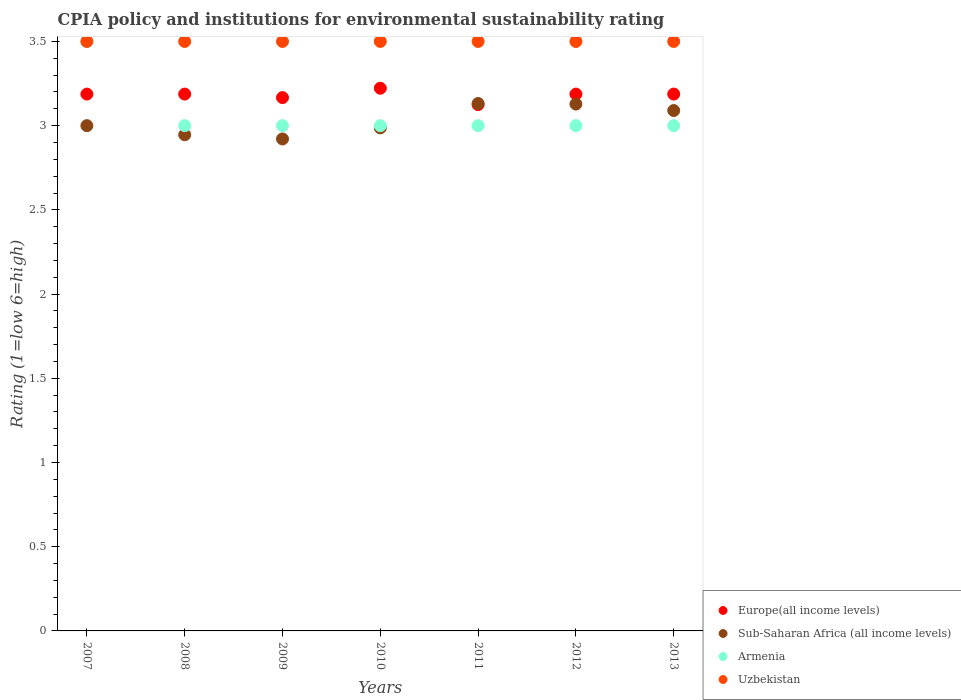How many different coloured dotlines are there?
Ensure brevity in your answer.  4. What is the CPIA rating in Sub-Saharan Africa (all income levels) in 2010?
Provide a short and direct response. 2.99. Across all years, what is the maximum CPIA rating in Uzbekistan?
Offer a very short reply. 3.5. Across all years, what is the minimum CPIA rating in Sub-Saharan Africa (all income levels)?
Offer a very short reply. 2.92. What is the total CPIA rating in Uzbekistan in the graph?
Ensure brevity in your answer.  24.5. What is the difference between the CPIA rating in Sub-Saharan Africa (all income levels) in 2009 and the CPIA rating in Uzbekistan in 2007?
Your response must be concise. -0.58. What is the average CPIA rating in Armenia per year?
Ensure brevity in your answer.  3.07. In the year 2007, what is the difference between the CPIA rating in Uzbekistan and CPIA rating in Sub-Saharan Africa (all income levels)?
Keep it short and to the point. 0.5. What is the ratio of the CPIA rating in Uzbekistan in 2008 to that in 2009?
Give a very brief answer. 1. Is the difference between the CPIA rating in Uzbekistan in 2008 and 2009 greater than the difference between the CPIA rating in Sub-Saharan Africa (all income levels) in 2008 and 2009?
Provide a succinct answer. No. What is the difference between the highest and the second highest CPIA rating in Sub-Saharan Africa (all income levels)?
Offer a terse response. 0. What is the difference between the highest and the lowest CPIA rating in Uzbekistan?
Ensure brevity in your answer.  0. In how many years, is the CPIA rating in Uzbekistan greater than the average CPIA rating in Uzbekistan taken over all years?
Keep it short and to the point. 0. Is the sum of the CPIA rating in Europe(all income levels) in 2010 and 2011 greater than the maximum CPIA rating in Armenia across all years?
Give a very brief answer. Yes. Is it the case that in every year, the sum of the CPIA rating in Armenia and CPIA rating in Europe(all income levels)  is greater than the CPIA rating in Uzbekistan?
Keep it short and to the point. Yes. Is the CPIA rating in Armenia strictly greater than the CPIA rating in Sub-Saharan Africa (all income levels) over the years?
Provide a succinct answer. No. Is the CPIA rating in Armenia strictly less than the CPIA rating in Sub-Saharan Africa (all income levels) over the years?
Your answer should be very brief. No. What is the difference between two consecutive major ticks on the Y-axis?
Your answer should be very brief. 0.5. Are the values on the major ticks of Y-axis written in scientific E-notation?
Provide a succinct answer. No. Does the graph contain any zero values?
Your answer should be very brief. No. Does the graph contain grids?
Your response must be concise. No. How are the legend labels stacked?
Give a very brief answer. Vertical. What is the title of the graph?
Ensure brevity in your answer.  CPIA policy and institutions for environmental sustainability rating. Does "French Polynesia" appear as one of the legend labels in the graph?
Your answer should be compact. No. What is the label or title of the X-axis?
Make the answer very short. Years. What is the label or title of the Y-axis?
Ensure brevity in your answer.  Rating (1=low 6=high). What is the Rating (1=low 6=high) in Europe(all income levels) in 2007?
Offer a very short reply. 3.19. What is the Rating (1=low 6=high) in Sub-Saharan Africa (all income levels) in 2007?
Give a very brief answer. 3. What is the Rating (1=low 6=high) of Armenia in 2007?
Your answer should be compact. 3.5. What is the Rating (1=low 6=high) of Uzbekistan in 2007?
Your answer should be compact. 3.5. What is the Rating (1=low 6=high) of Europe(all income levels) in 2008?
Give a very brief answer. 3.19. What is the Rating (1=low 6=high) of Sub-Saharan Africa (all income levels) in 2008?
Offer a terse response. 2.95. What is the Rating (1=low 6=high) of Uzbekistan in 2008?
Give a very brief answer. 3.5. What is the Rating (1=low 6=high) of Europe(all income levels) in 2009?
Your response must be concise. 3.17. What is the Rating (1=low 6=high) in Sub-Saharan Africa (all income levels) in 2009?
Offer a terse response. 2.92. What is the Rating (1=low 6=high) in Armenia in 2009?
Your answer should be very brief. 3. What is the Rating (1=low 6=high) of Uzbekistan in 2009?
Your answer should be very brief. 3.5. What is the Rating (1=low 6=high) in Europe(all income levels) in 2010?
Make the answer very short. 3.22. What is the Rating (1=low 6=high) in Sub-Saharan Africa (all income levels) in 2010?
Keep it short and to the point. 2.99. What is the Rating (1=low 6=high) of Armenia in 2010?
Provide a short and direct response. 3. What is the Rating (1=low 6=high) of Uzbekistan in 2010?
Ensure brevity in your answer.  3.5. What is the Rating (1=low 6=high) of Europe(all income levels) in 2011?
Your response must be concise. 3.12. What is the Rating (1=low 6=high) of Sub-Saharan Africa (all income levels) in 2011?
Your answer should be compact. 3.13. What is the Rating (1=low 6=high) in Uzbekistan in 2011?
Ensure brevity in your answer.  3.5. What is the Rating (1=low 6=high) of Europe(all income levels) in 2012?
Give a very brief answer. 3.19. What is the Rating (1=low 6=high) of Sub-Saharan Africa (all income levels) in 2012?
Your answer should be compact. 3.13. What is the Rating (1=low 6=high) in Uzbekistan in 2012?
Your answer should be compact. 3.5. What is the Rating (1=low 6=high) in Europe(all income levels) in 2013?
Give a very brief answer. 3.19. What is the Rating (1=low 6=high) of Sub-Saharan Africa (all income levels) in 2013?
Provide a short and direct response. 3.09. Across all years, what is the maximum Rating (1=low 6=high) in Europe(all income levels)?
Provide a short and direct response. 3.22. Across all years, what is the maximum Rating (1=low 6=high) of Sub-Saharan Africa (all income levels)?
Make the answer very short. 3.13. Across all years, what is the maximum Rating (1=low 6=high) of Armenia?
Offer a terse response. 3.5. Across all years, what is the minimum Rating (1=low 6=high) of Europe(all income levels)?
Provide a short and direct response. 3.12. Across all years, what is the minimum Rating (1=low 6=high) in Sub-Saharan Africa (all income levels)?
Your answer should be compact. 2.92. What is the total Rating (1=low 6=high) of Europe(all income levels) in the graph?
Offer a very short reply. 22.26. What is the total Rating (1=low 6=high) of Sub-Saharan Africa (all income levels) in the graph?
Your answer should be compact. 21.2. What is the total Rating (1=low 6=high) of Uzbekistan in the graph?
Ensure brevity in your answer.  24.5. What is the difference between the Rating (1=low 6=high) in Sub-Saharan Africa (all income levels) in 2007 and that in 2008?
Your answer should be compact. 0.05. What is the difference between the Rating (1=low 6=high) in Europe(all income levels) in 2007 and that in 2009?
Your response must be concise. 0.02. What is the difference between the Rating (1=low 6=high) of Sub-Saharan Africa (all income levels) in 2007 and that in 2009?
Your answer should be very brief. 0.08. What is the difference between the Rating (1=low 6=high) in Uzbekistan in 2007 and that in 2009?
Your response must be concise. 0. What is the difference between the Rating (1=low 6=high) of Europe(all income levels) in 2007 and that in 2010?
Provide a short and direct response. -0.03. What is the difference between the Rating (1=low 6=high) of Sub-Saharan Africa (all income levels) in 2007 and that in 2010?
Offer a terse response. 0.01. What is the difference between the Rating (1=low 6=high) in Armenia in 2007 and that in 2010?
Your answer should be very brief. 0.5. What is the difference between the Rating (1=low 6=high) in Uzbekistan in 2007 and that in 2010?
Offer a very short reply. 0. What is the difference between the Rating (1=low 6=high) in Europe(all income levels) in 2007 and that in 2011?
Your response must be concise. 0.06. What is the difference between the Rating (1=low 6=high) in Sub-Saharan Africa (all income levels) in 2007 and that in 2011?
Make the answer very short. -0.13. What is the difference between the Rating (1=low 6=high) of Armenia in 2007 and that in 2011?
Provide a succinct answer. 0.5. What is the difference between the Rating (1=low 6=high) in Europe(all income levels) in 2007 and that in 2012?
Offer a terse response. 0. What is the difference between the Rating (1=low 6=high) in Sub-Saharan Africa (all income levels) in 2007 and that in 2012?
Give a very brief answer. -0.13. What is the difference between the Rating (1=low 6=high) in Sub-Saharan Africa (all income levels) in 2007 and that in 2013?
Make the answer very short. -0.09. What is the difference between the Rating (1=low 6=high) of Armenia in 2007 and that in 2013?
Offer a very short reply. 0.5. What is the difference between the Rating (1=low 6=high) in Europe(all income levels) in 2008 and that in 2009?
Make the answer very short. 0.02. What is the difference between the Rating (1=low 6=high) in Sub-Saharan Africa (all income levels) in 2008 and that in 2009?
Provide a succinct answer. 0.02. What is the difference between the Rating (1=low 6=high) in Uzbekistan in 2008 and that in 2009?
Make the answer very short. 0. What is the difference between the Rating (1=low 6=high) in Europe(all income levels) in 2008 and that in 2010?
Give a very brief answer. -0.03. What is the difference between the Rating (1=low 6=high) of Sub-Saharan Africa (all income levels) in 2008 and that in 2010?
Make the answer very short. -0.04. What is the difference between the Rating (1=low 6=high) in Armenia in 2008 and that in 2010?
Make the answer very short. 0. What is the difference between the Rating (1=low 6=high) of Europe(all income levels) in 2008 and that in 2011?
Offer a terse response. 0.06. What is the difference between the Rating (1=low 6=high) in Sub-Saharan Africa (all income levels) in 2008 and that in 2011?
Your answer should be very brief. -0.19. What is the difference between the Rating (1=low 6=high) in Armenia in 2008 and that in 2011?
Offer a very short reply. 0. What is the difference between the Rating (1=low 6=high) of Europe(all income levels) in 2008 and that in 2012?
Give a very brief answer. 0. What is the difference between the Rating (1=low 6=high) of Sub-Saharan Africa (all income levels) in 2008 and that in 2012?
Your answer should be very brief. -0.18. What is the difference between the Rating (1=low 6=high) in Armenia in 2008 and that in 2012?
Your answer should be very brief. 0. What is the difference between the Rating (1=low 6=high) of Sub-Saharan Africa (all income levels) in 2008 and that in 2013?
Your response must be concise. -0.14. What is the difference between the Rating (1=low 6=high) in Uzbekistan in 2008 and that in 2013?
Your response must be concise. 0. What is the difference between the Rating (1=low 6=high) of Europe(all income levels) in 2009 and that in 2010?
Ensure brevity in your answer.  -0.06. What is the difference between the Rating (1=low 6=high) of Sub-Saharan Africa (all income levels) in 2009 and that in 2010?
Make the answer very short. -0.07. What is the difference between the Rating (1=low 6=high) in Armenia in 2009 and that in 2010?
Ensure brevity in your answer.  0. What is the difference between the Rating (1=low 6=high) in Europe(all income levels) in 2009 and that in 2011?
Keep it short and to the point. 0.04. What is the difference between the Rating (1=low 6=high) of Sub-Saharan Africa (all income levels) in 2009 and that in 2011?
Keep it short and to the point. -0.21. What is the difference between the Rating (1=low 6=high) in Uzbekistan in 2009 and that in 2011?
Your response must be concise. 0. What is the difference between the Rating (1=low 6=high) in Europe(all income levels) in 2009 and that in 2012?
Provide a succinct answer. -0.02. What is the difference between the Rating (1=low 6=high) of Sub-Saharan Africa (all income levels) in 2009 and that in 2012?
Offer a terse response. -0.21. What is the difference between the Rating (1=low 6=high) of Uzbekistan in 2009 and that in 2012?
Make the answer very short. 0. What is the difference between the Rating (1=low 6=high) in Europe(all income levels) in 2009 and that in 2013?
Keep it short and to the point. -0.02. What is the difference between the Rating (1=low 6=high) in Sub-Saharan Africa (all income levels) in 2009 and that in 2013?
Provide a succinct answer. -0.17. What is the difference between the Rating (1=low 6=high) of Europe(all income levels) in 2010 and that in 2011?
Your answer should be compact. 0.1. What is the difference between the Rating (1=low 6=high) in Sub-Saharan Africa (all income levels) in 2010 and that in 2011?
Provide a succinct answer. -0.14. What is the difference between the Rating (1=low 6=high) in Armenia in 2010 and that in 2011?
Your answer should be compact. 0. What is the difference between the Rating (1=low 6=high) in Europe(all income levels) in 2010 and that in 2012?
Make the answer very short. 0.03. What is the difference between the Rating (1=low 6=high) in Sub-Saharan Africa (all income levels) in 2010 and that in 2012?
Make the answer very short. -0.14. What is the difference between the Rating (1=low 6=high) of Armenia in 2010 and that in 2012?
Give a very brief answer. 0. What is the difference between the Rating (1=low 6=high) of Europe(all income levels) in 2010 and that in 2013?
Make the answer very short. 0.03. What is the difference between the Rating (1=low 6=high) in Sub-Saharan Africa (all income levels) in 2010 and that in 2013?
Provide a succinct answer. -0.1. What is the difference between the Rating (1=low 6=high) of Armenia in 2010 and that in 2013?
Offer a very short reply. 0. What is the difference between the Rating (1=low 6=high) of Uzbekistan in 2010 and that in 2013?
Keep it short and to the point. 0. What is the difference between the Rating (1=low 6=high) in Europe(all income levels) in 2011 and that in 2012?
Your answer should be very brief. -0.06. What is the difference between the Rating (1=low 6=high) in Sub-Saharan Africa (all income levels) in 2011 and that in 2012?
Give a very brief answer. 0. What is the difference between the Rating (1=low 6=high) in Armenia in 2011 and that in 2012?
Ensure brevity in your answer.  0. What is the difference between the Rating (1=low 6=high) in Uzbekistan in 2011 and that in 2012?
Provide a succinct answer. 0. What is the difference between the Rating (1=low 6=high) of Europe(all income levels) in 2011 and that in 2013?
Offer a very short reply. -0.06. What is the difference between the Rating (1=low 6=high) in Sub-Saharan Africa (all income levels) in 2011 and that in 2013?
Your response must be concise. 0.04. What is the difference between the Rating (1=low 6=high) in Armenia in 2011 and that in 2013?
Give a very brief answer. 0. What is the difference between the Rating (1=low 6=high) in Europe(all income levels) in 2012 and that in 2013?
Ensure brevity in your answer.  0. What is the difference between the Rating (1=low 6=high) in Sub-Saharan Africa (all income levels) in 2012 and that in 2013?
Make the answer very short. 0.04. What is the difference between the Rating (1=low 6=high) in Armenia in 2012 and that in 2013?
Your answer should be very brief. 0. What is the difference between the Rating (1=low 6=high) in Europe(all income levels) in 2007 and the Rating (1=low 6=high) in Sub-Saharan Africa (all income levels) in 2008?
Keep it short and to the point. 0.24. What is the difference between the Rating (1=low 6=high) in Europe(all income levels) in 2007 and the Rating (1=low 6=high) in Armenia in 2008?
Offer a very short reply. 0.19. What is the difference between the Rating (1=low 6=high) in Europe(all income levels) in 2007 and the Rating (1=low 6=high) in Uzbekistan in 2008?
Provide a short and direct response. -0.31. What is the difference between the Rating (1=low 6=high) in Sub-Saharan Africa (all income levels) in 2007 and the Rating (1=low 6=high) in Armenia in 2008?
Give a very brief answer. 0. What is the difference between the Rating (1=low 6=high) of Armenia in 2007 and the Rating (1=low 6=high) of Uzbekistan in 2008?
Ensure brevity in your answer.  0. What is the difference between the Rating (1=low 6=high) of Europe(all income levels) in 2007 and the Rating (1=low 6=high) of Sub-Saharan Africa (all income levels) in 2009?
Your answer should be compact. 0.27. What is the difference between the Rating (1=low 6=high) in Europe(all income levels) in 2007 and the Rating (1=low 6=high) in Armenia in 2009?
Ensure brevity in your answer.  0.19. What is the difference between the Rating (1=low 6=high) in Europe(all income levels) in 2007 and the Rating (1=low 6=high) in Uzbekistan in 2009?
Provide a succinct answer. -0.31. What is the difference between the Rating (1=low 6=high) in Armenia in 2007 and the Rating (1=low 6=high) in Uzbekistan in 2009?
Your answer should be very brief. 0. What is the difference between the Rating (1=low 6=high) in Europe(all income levels) in 2007 and the Rating (1=low 6=high) in Sub-Saharan Africa (all income levels) in 2010?
Make the answer very short. 0.2. What is the difference between the Rating (1=low 6=high) of Europe(all income levels) in 2007 and the Rating (1=low 6=high) of Armenia in 2010?
Offer a very short reply. 0.19. What is the difference between the Rating (1=low 6=high) in Europe(all income levels) in 2007 and the Rating (1=low 6=high) in Uzbekistan in 2010?
Offer a very short reply. -0.31. What is the difference between the Rating (1=low 6=high) in Sub-Saharan Africa (all income levels) in 2007 and the Rating (1=low 6=high) in Uzbekistan in 2010?
Offer a terse response. -0.5. What is the difference between the Rating (1=low 6=high) of Armenia in 2007 and the Rating (1=low 6=high) of Uzbekistan in 2010?
Offer a terse response. 0. What is the difference between the Rating (1=low 6=high) in Europe(all income levels) in 2007 and the Rating (1=low 6=high) in Sub-Saharan Africa (all income levels) in 2011?
Offer a terse response. 0.06. What is the difference between the Rating (1=low 6=high) of Europe(all income levels) in 2007 and the Rating (1=low 6=high) of Armenia in 2011?
Your answer should be very brief. 0.19. What is the difference between the Rating (1=low 6=high) in Europe(all income levels) in 2007 and the Rating (1=low 6=high) in Uzbekistan in 2011?
Your answer should be compact. -0.31. What is the difference between the Rating (1=low 6=high) in Sub-Saharan Africa (all income levels) in 2007 and the Rating (1=low 6=high) in Uzbekistan in 2011?
Your answer should be very brief. -0.5. What is the difference between the Rating (1=low 6=high) in Armenia in 2007 and the Rating (1=low 6=high) in Uzbekistan in 2011?
Ensure brevity in your answer.  0. What is the difference between the Rating (1=low 6=high) in Europe(all income levels) in 2007 and the Rating (1=low 6=high) in Sub-Saharan Africa (all income levels) in 2012?
Make the answer very short. 0.06. What is the difference between the Rating (1=low 6=high) in Europe(all income levels) in 2007 and the Rating (1=low 6=high) in Armenia in 2012?
Provide a succinct answer. 0.19. What is the difference between the Rating (1=low 6=high) in Europe(all income levels) in 2007 and the Rating (1=low 6=high) in Uzbekistan in 2012?
Your response must be concise. -0.31. What is the difference between the Rating (1=low 6=high) in Sub-Saharan Africa (all income levels) in 2007 and the Rating (1=low 6=high) in Armenia in 2012?
Ensure brevity in your answer.  0. What is the difference between the Rating (1=low 6=high) of Europe(all income levels) in 2007 and the Rating (1=low 6=high) of Sub-Saharan Africa (all income levels) in 2013?
Your answer should be very brief. 0.1. What is the difference between the Rating (1=low 6=high) in Europe(all income levels) in 2007 and the Rating (1=low 6=high) in Armenia in 2013?
Provide a short and direct response. 0.19. What is the difference between the Rating (1=low 6=high) in Europe(all income levels) in 2007 and the Rating (1=low 6=high) in Uzbekistan in 2013?
Ensure brevity in your answer.  -0.31. What is the difference between the Rating (1=low 6=high) in Sub-Saharan Africa (all income levels) in 2007 and the Rating (1=low 6=high) in Uzbekistan in 2013?
Your answer should be very brief. -0.5. What is the difference between the Rating (1=low 6=high) of Armenia in 2007 and the Rating (1=low 6=high) of Uzbekistan in 2013?
Your response must be concise. 0. What is the difference between the Rating (1=low 6=high) of Europe(all income levels) in 2008 and the Rating (1=low 6=high) of Sub-Saharan Africa (all income levels) in 2009?
Offer a very short reply. 0.27. What is the difference between the Rating (1=low 6=high) in Europe(all income levels) in 2008 and the Rating (1=low 6=high) in Armenia in 2009?
Keep it short and to the point. 0.19. What is the difference between the Rating (1=low 6=high) in Europe(all income levels) in 2008 and the Rating (1=low 6=high) in Uzbekistan in 2009?
Keep it short and to the point. -0.31. What is the difference between the Rating (1=low 6=high) in Sub-Saharan Africa (all income levels) in 2008 and the Rating (1=low 6=high) in Armenia in 2009?
Your answer should be compact. -0.05. What is the difference between the Rating (1=low 6=high) in Sub-Saharan Africa (all income levels) in 2008 and the Rating (1=low 6=high) in Uzbekistan in 2009?
Your answer should be compact. -0.55. What is the difference between the Rating (1=low 6=high) in Armenia in 2008 and the Rating (1=low 6=high) in Uzbekistan in 2009?
Provide a succinct answer. -0.5. What is the difference between the Rating (1=low 6=high) of Europe(all income levels) in 2008 and the Rating (1=low 6=high) of Sub-Saharan Africa (all income levels) in 2010?
Provide a short and direct response. 0.2. What is the difference between the Rating (1=low 6=high) of Europe(all income levels) in 2008 and the Rating (1=low 6=high) of Armenia in 2010?
Keep it short and to the point. 0.19. What is the difference between the Rating (1=low 6=high) in Europe(all income levels) in 2008 and the Rating (1=low 6=high) in Uzbekistan in 2010?
Keep it short and to the point. -0.31. What is the difference between the Rating (1=low 6=high) in Sub-Saharan Africa (all income levels) in 2008 and the Rating (1=low 6=high) in Armenia in 2010?
Your answer should be very brief. -0.05. What is the difference between the Rating (1=low 6=high) in Sub-Saharan Africa (all income levels) in 2008 and the Rating (1=low 6=high) in Uzbekistan in 2010?
Ensure brevity in your answer.  -0.55. What is the difference between the Rating (1=low 6=high) of Europe(all income levels) in 2008 and the Rating (1=low 6=high) of Sub-Saharan Africa (all income levels) in 2011?
Ensure brevity in your answer.  0.06. What is the difference between the Rating (1=low 6=high) in Europe(all income levels) in 2008 and the Rating (1=low 6=high) in Armenia in 2011?
Keep it short and to the point. 0.19. What is the difference between the Rating (1=low 6=high) in Europe(all income levels) in 2008 and the Rating (1=low 6=high) in Uzbekistan in 2011?
Provide a succinct answer. -0.31. What is the difference between the Rating (1=low 6=high) in Sub-Saharan Africa (all income levels) in 2008 and the Rating (1=low 6=high) in Armenia in 2011?
Ensure brevity in your answer.  -0.05. What is the difference between the Rating (1=low 6=high) of Sub-Saharan Africa (all income levels) in 2008 and the Rating (1=low 6=high) of Uzbekistan in 2011?
Keep it short and to the point. -0.55. What is the difference between the Rating (1=low 6=high) of Europe(all income levels) in 2008 and the Rating (1=low 6=high) of Sub-Saharan Africa (all income levels) in 2012?
Your response must be concise. 0.06. What is the difference between the Rating (1=low 6=high) in Europe(all income levels) in 2008 and the Rating (1=low 6=high) in Armenia in 2012?
Your answer should be compact. 0.19. What is the difference between the Rating (1=low 6=high) in Europe(all income levels) in 2008 and the Rating (1=low 6=high) in Uzbekistan in 2012?
Make the answer very short. -0.31. What is the difference between the Rating (1=low 6=high) of Sub-Saharan Africa (all income levels) in 2008 and the Rating (1=low 6=high) of Armenia in 2012?
Offer a terse response. -0.05. What is the difference between the Rating (1=low 6=high) in Sub-Saharan Africa (all income levels) in 2008 and the Rating (1=low 6=high) in Uzbekistan in 2012?
Your response must be concise. -0.55. What is the difference between the Rating (1=low 6=high) in Armenia in 2008 and the Rating (1=low 6=high) in Uzbekistan in 2012?
Your answer should be compact. -0.5. What is the difference between the Rating (1=low 6=high) of Europe(all income levels) in 2008 and the Rating (1=low 6=high) of Sub-Saharan Africa (all income levels) in 2013?
Keep it short and to the point. 0.1. What is the difference between the Rating (1=low 6=high) in Europe(all income levels) in 2008 and the Rating (1=low 6=high) in Armenia in 2013?
Ensure brevity in your answer.  0.19. What is the difference between the Rating (1=low 6=high) in Europe(all income levels) in 2008 and the Rating (1=low 6=high) in Uzbekistan in 2013?
Keep it short and to the point. -0.31. What is the difference between the Rating (1=low 6=high) of Sub-Saharan Africa (all income levels) in 2008 and the Rating (1=low 6=high) of Armenia in 2013?
Ensure brevity in your answer.  -0.05. What is the difference between the Rating (1=low 6=high) of Sub-Saharan Africa (all income levels) in 2008 and the Rating (1=low 6=high) of Uzbekistan in 2013?
Give a very brief answer. -0.55. What is the difference between the Rating (1=low 6=high) of Armenia in 2008 and the Rating (1=low 6=high) of Uzbekistan in 2013?
Give a very brief answer. -0.5. What is the difference between the Rating (1=low 6=high) in Europe(all income levels) in 2009 and the Rating (1=low 6=high) in Sub-Saharan Africa (all income levels) in 2010?
Your answer should be very brief. 0.18. What is the difference between the Rating (1=low 6=high) in Europe(all income levels) in 2009 and the Rating (1=low 6=high) in Armenia in 2010?
Provide a short and direct response. 0.17. What is the difference between the Rating (1=low 6=high) in Sub-Saharan Africa (all income levels) in 2009 and the Rating (1=low 6=high) in Armenia in 2010?
Provide a short and direct response. -0.08. What is the difference between the Rating (1=low 6=high) in Sub-Saharan Africa (all income levels) in 2009 and the Rating (1=low 6=high) in Uzbekistan in 2010?
Provide a short and direct response. -0.58. What is the difference between the Rating (1=low 6=high) of Europe(all income levels) in 2009 and the Rating (1=low 6=high) of Sub-Saharan Africa (all income levels) in 2011?
Provide a succinct answer. 0.04. What is the difference between the Rating (1=low 6=high) in Europe(all income levels) in 2009 and the Rating (1=low 6=high) in Armenia in 2011?
Keep it short and to the point. 0.17. What is the difference between the Rating (1=low 6=high) in Europe(all income levels) in 2009 and the Rating (1=low 6=high) in Uzbekistan in 2011?
Your answer should be very brief. -0.33. What is the difference between the Rating (1=low 6=high) of Sub-Saharan Africa (all income levels) in 2009 and the Rating (1=low 6=high) of Armenia in 2011?
Offer a very short reply. -0.08. What is the difference between the Rating (1=low 6=high) of Sub-Saharan Africa (all income levels) in 2009 and the Rating (1=low 6=high) of Uzbekistan in 2011?
Your answer should be compact. -0.58. What is the difference between the Rating (1=low 6=high) of Europe(all income levels) in 2009 and the Rating (1=low 6=high) of Sub-Saharan Africa (all income levels) in 2012?
Give a very brief answer. 0.04. What is the difference between the Rating (1=low 6=high) of Europe(all income levels) in 2009 and the Rating (1=low 6=high) of Armenia in 2012?
Your answer should be very brief. 0.17. What is the difference between the Rating (1=low 6=high) in Europe(all income levels) in 2009 and the Rating (1=low 6=high) in Uzbekistan in 2012?
Keep it short and to the point. -0.33. What is the difference between the Rating (1=low 6=high) in Sub-Saharan Africa (all income levels) in 2009 and the Rating (1=low 6=high) in Armenia in 2012?
Provide a succinct answer. -0.08. What is the difference between the Rating (1=low 6=high) in Sub-Saharan Africa (all income levels) in 2009 and the Rating (1=low 6=high) in Uzbekistan in 2012?
Provide a succinct answer. -0.58. What is the difference between the Rating (1=low 6=high) of Armenia in 2009 and the Rating (1=low 6=high) of Uzbekistan in 2012?
Ensure brevity in your answer.  -0.5. What is the difference between the Rating (1=low 6=high) of Europe(all income levels) in 2009 and the Rating (1=low 6=high) of Sub-Saharan Africa (all income levels) in 2013?
Provide a succinct answer. 0.08. What is the difference between the Rating (1=low 6=high) in Europe(all income levels) in 2009 and the Rating (1=low 6=high) in Armenia in 2013?
Provide a succinct answer. 0.17. What is the difference between the Rating (1=low 6=high) of Europe(all income levels) in 2009 and the Rating (1=low 6=high) of Uzbekistan in 2013?
Give a very brief answer. -0.33. What is the difference between the Rating (1=low 6=high) of Sub-Saharan Africa (all income levels) in 2009 and the Rating (1=low 6=high) of Armenia in 2013?
Offer a very short reply. -0.08. What is the difference between the Rating (1=low 6=high) in Sub-Saharan Africa (all income levels) in 2009 and the Rating (1=low 6=high) in Uzbekistan in 2013?
Offer a terse response. -0.58. What is the difference between the Rating (1=low 6=high) of Europe(all income levels) in 2010 and the Rating (1=low 6=high) of Sub-Saharan Africa (all income levels) in 2011?
Your answer should be very brief. 0.09. What is the difference between the Rating (1=low 6=high) of Europe(all income levels) in 2010 and the Rating (1=low 6=high) of Armenia in 2011?
Your answer should be compact. 0.22. What is the difference between the Rating (1=low 6=high) in Europe(all income levels) in 2010 and the Rating (1=low 6=high) in Uzbekistan in 2011?
Your answer should be very brief. -0.28. What is the difference between the Rating (1=low 6=high) in Sub-Saharan Africa (all income levels) in 2010 and the Rating (1=low 6=high) in Armenia in 2011?
Your answer should be compact. -0.01. What is the difference between the Rating (1=low 6=high) of Sub-Saharan Africa (all income levels) in 2010 and the Rating (1=low 6=high) of Uzbekistan in 2011?
Make the answer very short. -0.51. What is the difference between the Rating (1=low 6=high) in Armenia in 2010 and the Rating (1=low 6=high) in Uzbekistan in 2011?
Keep it short and to the point. -0.5. What is the difference between the Rating (1=low 6=high) of Europe(all income levels) in 2010 and the Rating (1=low 6=high) of Sub-Saharan Africa (all income levels) in 2012?
Your answer should be very brief. 0.09. What is the difference between the Rating (1=low 6=high) of Europe(all income levels) in 2010 and the Rating (1=low 6=high) of Armenia in 2012?
Keep it short and to the point. 0.22. What is the difference between the Rating (1=low 6=high) in Europe(all income levels) in 2010 and the Rating (1=low 6=high) in Uzbekistan in 2012?
Make the answer very short. -0.28. What is the difference between the Rating (1=low 6=high) in Sub-Saharan Africa (all income levels) in 2010 and the Rating (1=low 6=high) in Armenia in 2012?
Your answer should be compact. -0.01. What is the difference between the Rating (1=low 6=high) in Sub-Saharan Africa (all income levels) in 2010 and the Rating (1=low 6=high) in Uzbekistan in 2012?
Give a very brief answer. -0.51. What is the difference between the Rating (1=low 6=high) of Armenia in 2010 and the Rating (1=low 6=high) of Uzbekistan in 2012?
Your response must be concise. -0.5. What is the difference between the Rating (1=low 6=high) in Europe(all income levels) in 2010 and the Rating (1=low 6=high) in Sub-Saharan Africa (all income levels) in 2013?
Make the answer very short. 0.13. What is the difference between the Rating (1=low 6=high) of Europe(all income levels) in 2010 and the Rating (1=low 6=high) of Armenia in 2013?
Your answer should be very brief. 0.22. What is the difference between the Rating (1=low 6=high) in Europe(all income levels) in 2010 and the Rating (1=low 6=high) in Uzbekistan in 2013?
Your response must be concise. -0.28. What is the difference between the Rating (1=low 6=high) in Sub-Saharan Africa (all income levels) in 2010 and the Rating (1=low 6=high) in Armenia in 2013?
Provide a succinct answer. -0.01. What is the difference between the Rating (1=low 6=high) of Sub-Saharan Africa (all income levels) in 2010 and the Rating (1=low 6=high) of Uzbekistan in 2013?
Provide a short and direct response. -0.51. What is the difference between the Rating (1=low 6=high) of Europe(all income levels) in 2011 and the Rating (1=low 6=high) of Sub-Saharan Africa (all income levels) in 2012?
Provide a short and direct response. -0. What is the difference between the Rating (1=low 6=high) in Europe(all income levels) in 2011 and the Rating (1=low 6=high) in Uzbekistan in 2012?
Keep it short and to the point. -0.38. What is the difference between the Rating (1=low 6=high) of Sub-Saharan Africa (all income levels) in 2011 and the Rating (1=low 6=high) of Armenia in 2012?
Provide a succinct answer. 0.13. What is the difference between the Rating (1=low 6=high) of Sub-Saharan Africa (all income levels) in 2011 and the Rating (1=low 6=high) of Uzbekistan in 2012?
Give a very brief answer. -0.37. What is the difference between the Rating (1=low 6=high) of Armenia in 2011 and the Rating (1=low 6=high) of Uzbekistan in 2012?
Make the answer very short. -0.5. What is the difference between the Rating (1=low 6=high) in Europe(all income levels) in 2011 and the Rating (1=low 6=high) in Sub-Saharan Africa (all income levels) in 2013?
Your answer should be very brief. 0.04. What is the difference between the Rating (1=low 6=high) in Europe(all income levels) in 2011 and the Rating (1=low 6=high) in Uzbekistan in 2013?
Provide a succinct answer. -0.38. What is the difference between the Rating (1=low 6=high) in Sub-Saharan Africa (all income levels) in 2011 and the Rating (1=low 6=high) in Armenia in 2013?
Make the answer very short. 0.13. What is the difference between the Rating (1=low 6=high) of Sub-Saharan Africa (all income levels) in 2011 and the Rating (1=low 6=high) of Uzbekistan in 2013?
Make the answer very short. -0.37. What is the difference between the Rating (1=low 6=high) of Armenia in 2011 and the Rating (1=low 6=high) of Uzbekistan in 2013?
Provide a short and direct response. -0.5. What is the difference between the Rating (1=low 6=high) of Europe(all income levels) in 2012 and the Rating (1=low 6=high) of Sub-Saharan Africa (all income levels) in 2013?
Your answer should be very brief. 0.1. What is the difference between the Rating (1=low 6=high) in Europe(all income levels) in 2012 and the Rating (1=low 6=high) in Armenia in 2013?
Your answer should be compact. 0.19. What is the difference between the Rating (1=low 6=high) of Europe(all income levels) in 2012 and the Rating (1=low 6=high) of Uzbekistan in 2013?
Keep it short and to the point. -0.31. What is the difference between the Rating (1=low 6=high) in Sub-Saharan Africa (all income levels) in 2012 and the Rating (1=low 6=high) in Armenia in 2013?
Your response must be concise. 0.13. What is the difference between the Rating (1=low 6=high) in Sub-Saharan Africa (all income levels) in 2012 and the Rating (1=low 6=high) in Uzbekistan in 2013?
Provide a short and direct response. -0.37. What is the average Rating (1=low 6=high) of Europe(all income levels) per year?
Your response must be concise. 3.18. What is the average Rating (1=low 6=high) in Sub-Saharan Africa (all income levels) per year?
Provide a succinct answer. 3.03. What is the average Rating (1=low 6=high) in Armenia per year?
Offer a very short reply. 3.07. What is the average Rating (1=low 6=high) in Uzbekistan per year?
Give a very brief answer. 3.5. In the year 2007, what is the difference between the Rating (1=low 6=high) in Europe(all income levels) and Rating (1=low 6=high) in Sub-Saharan Africa (all income levels)?
Your answer should be very brief. 0.19. In the year 2007, what is the difference between the Rating (1=low 6=high) in Europe(all income levels) and Rating (1=low 6=high) in Armenia?
Ensure brevity in your answer.  -0.31. In the year 2007, what is the difference between the Rating (1=low 6=high) of Europe(all income levels) and Rating (1=low 6=high) of Uzbekistan?
Make the answer very short. -0.31. In the year 2007, what is the difference between the Rating (1=low 6=high) in Sub-Saharan Africa (all income levels) and Rating (1=low 6=high) in Uzbekistan?
Your response must be concise. -0.5. In the year 2008, what is the difference between the Rating (1=low 6=high) of Europe(all income levels) and Rating (1=low 6=high) of Sub-Saharan Africa (all income levels)?
Your response must be concise. 0.24. In the year 2008, what is the difference between the Rating (1=low 6=high) of Europe(all income levels) and Rating (1=low 6=high) of Armenia?
Offer a very short reply. 0.19. In the year 2008, what is the difference between the Rating (1=low 6=high) in Europe(all income levels) and Rating (1=low 6=high) in Uzbekistan?
Your answer should be compact. -0.31. In the year 2008, what is the difference between the Rating (1=low 6=high) in Sub-Saharan Africa (all income levels) and Rating (1=low 6=high) in Armenia?
Ensure brevity in your answer.  -0.05. In the year 2008, what is the difference between the Rating (1=low 6=high) of Sub-Saharan Africa (all income levels) and Rating (1=low 6=high) of Uzbekistan?
Provide a short and direct response. -0.55. In the year 2008, what is the difference between the Rating (1=low 6=high) of Armenia and Rating (1=low 6=high) of Uzbekistan?
Offer a very short reply. -0.5. In the year 2009, what is the difference between the Rating (1=low 6=high) in Europe(all income levels) and Rating (1=low 6=high) in Sub-Saharan Africa (all income levels)?
Give a very brief answer. 0.25. In the year 2009, what is the difference between the Rating (1=low 6=high) of Europe(all income levels) and Rating (1=low 6=high) of Armenia?
Make the answer very short. 0.17. In the year 2009, what is the difference between the Rating (1=low 6=high) in Sub-Saharan Africa (all income levels) and Rating (1=low 6=high) in Armenia?
Your answer should be compact. -0.08. In the year 2009, what is the difference between the Rating (1=low 6=high) of Sub-Saharan Africa (all income levels) and Rating (1=low 6=high) of Uzbekistan?
Your answer should be compact. -0.58. In the year 2009, what is the difference between the Rating (1=low 6=high) of Armenia and Rating (1=low 6=high) of Uzbekistan?
Your answer should be very brief. -0.5. In the year 2010, what is the difference between the Rating (1=low 6=high) in Europe(all income levels) and Rating (1=low 6=high) in Sub-Saharan Africa (all income levels)?
Your answer should be very brief. 0.24. In the year 2010, what is the difference between the Rating (1=low 6=high) in Europe(all income levels) and Rating (1=low 6=high) in Armenia?
Give a very brief answer. 0.22. In the year 2010, what is the difference between the Rating (1=low 6=high) in Europe(all income levels) and Rating (1=low 6=high) in Uzbekistan?
Your response must be concise. -0.28. In the year 2010, what is the difference between the Rating (1=low 6=high) in Sub-Saharan Africa (all income levels) and Rating (1=low 6=high) in Armenia?
Keep it short and to the point. -0.01. In the year 2010, what is the difference between the Rating (1=low 6=high) of Sub-Saharan Africa (all income levels) and Rating (1=low 6=high) of Uzbekistan?
Provide a short and direct response. -0.51. In the year 2010, what is the difference between the Rating (1=low 6=high) of Armenia and Rating (1=low 6=high) of Uzbekistan?
Make the answer very short. -0.5. In the year 2011, what is the difference between the Rating (1=low 6=high) of Europe(all income levels) and Rating (1=low 6=high) of Sub-Saharan Africa (all income levels)?
Keep it short and to the point. -0.01. In the year 2011, what is the difference between the Rating (1=low 6=high) of Europe(all income levels) and Rating (1=low 6=high) of Armenia?
Offer a very short reply. 0.12. In the year 2011, what is the difference between the Rating (1=low 6=high) of Europe(all income levels) and Rating (1=low 6=high) of Uzbekistan?
Your answer should be compact. -0.38. In the year 2011, what is the difference between the Rating (1=low 6=high) of Sub-Saharan Africa (all income levels) and Rating (1=low 6=high) of Armenia?
Your answer should be very brief. 0.13. In the year 2011, what is the difference between the Rating (1=low 6=high) of Sub-Saharan Africa (all income levels) and Rating (1=low 6=high) of Uzbekistan?
Offer a terse response. -0.37. In the year 2012, what is the difference between the Rating (1=low 6=high) of Europe(all income levels) and Rating (1=low 6=high) of Sub-Saharan Africa (all income levels)?
Offer a terse response. 0.06. In the year 2012, what is the difference between the Rating (1=low 6=high) of Europe(all income levels) and Rating (1=low 6=high) of Armenia?
Your answer should be very brief. 0.19. In the year 2012, what is the difference between the Rating (1=low 6=high) of Europe(all income levels) and Rating (1=low 6=high) of Uzbekistan?
Your answer should be very brief. -0.31. In the year 2012, what is the difference between the Rating (1=low 6=high) in Sub-Saharan Africa (all income levels) and Rating (1=low 6=high) in Armenia?
Your response must be concise. 0.13. In the year 2012, what is the difference between the Rating (1=low 6=high) of Sub-Saharan Africa (all income levels) and Rating (1=low 6=high) of Uzbekistan?
Ensure brevity in your answer.  -0.37. In the year 2012, what is the difference between the Rating (1=low 6=high) of Armenia and Rating (1=low 6=high) of Uzbekistan?
Offer a very short reply. -0.5. In the year 2013, what is the difference between the Rating (1=low 6=high) of Europe(all income levels) and Rating (1=low 6=high) of Sub-Saharan Africa (all income levels)?
Your response must be concise. 0.1. In the year 2013, what is the difference between the Rating (1=low 6=high) in Europe(all income levels) and Rating (1=low 6=high) in Armenia?
Keep it short and to the point. 0.19. In the year 2013, what is the difference between the Rating (1=low 6=high) of Europe(all income levels) and Rating (1=low 6=high) of Uzbekistan?
Offer a very short reply. -0.31. In the year 2013, what is the difference between the Rating (1=low 6=high) in Sub-Saharan Africa (all income levels) and Rating (1=low 6=high) in Armenia?
Keep it short and to the point. 0.09. In the year 2013, what is the difference between the Rating (1=low 6=high) in Sub-Saharan Africa (all income levels) and Rating (1=low 6=high) in Uzbekistan?
Give a very brief answer. -0.41. What is the ratio of the Rating (1=low 6=high) in Sub-Saharan Africa (all income levels) in 2007 to that in 2008?
Keep it short and to the point. 1.02. What is the ratio of the Rating (1=low 6=high) in Armenia in 2007 to that in 2008?
Keep it short and to the point. 1.17. What is the ratio of the Rating (1=low 6=high) in Europe(all income levels) in 2007 to that in 2009?
Keep it short and to the point. 1.01. What is the ratio of the Rating (1=low 6=high) in Armenia in 2007 to that in 2009?
Your answer should be very brief. 1.17. What is the ratio of the Rating (1=low 6=high) in Europe(all income levels) in 2007 to that in 2010?
Give a very brief answer. 0.99. What is the ratio of the Rating (1=low 6=high) in Sub-Saharan Africa (all income levels) in 2007 to that in 2010?
Provide a succinct answer. 1. What is the ratio of the Rating (1=low 6=high) in Sub-Saharan Africa (all income levels) in 2007 to that in 2011?
Give a very brief answer. 0.96. What is the ratio of the Rating (1=low 6=high) of Armenia in 2007 to that in 2011?
Give a very brief answer. 1.17. What is the ratio of the Rating (1=low 6=high) in Europe(all income levels) in 2007 to that in 2012?
Keep it short and to the point. 1. What is the ratio of the Rating (1=low 6=high) of Europe(all income levels) in 2008 to that in 2009?
Your response must be concise. 1.01. What is the ratio of the Rating (1=low 6=high) of Sub-Saharan Africa (all income levels) in 2008 to that in 2009?
Your response must be concise. 1.01. What is the ratio of the Rating (1=low 6=high) in Sub-Saharan Africa (all income levels) in 2008 to that in 2010?
Make the answer very short. 0.99. What is the ratio of the Rating (1=low 6=high) of Europe(all income levels) in 2008 to that in 2011?
Give a very brief answer. 1.02. What is the ratio of the Rating (1=low 6=high) in Sub-Saharan Africa (all income levels) in 2008 to that in 2011?
Provide a succinct answer. 0.94. What is the ratio of the Rating (1=low 6=high) of Armenia in 2008 to that in 2011?
Provide a short and direct response. 1. What is the ratio of the Rating (1=low 6=high) of Europe(all income levels) in 2008 to that in 2012?
Your response must be concise. 1. What is the ratio of the Rating (1=low 6=high) in Sub-Saharan Africa (all income levels) in 2008 to that in 2012?
Provide a succinct answer. 0.94. What is the ratio of the Rating (1=low 6=high) of Armenia in 2008 to that in 2012?
Offer a very short reply. 1. What is the ratio of the Rating (1=low 6=high) of Sub-Saharan Africa (all income levels) in 2008 to that in 2013?
Your response must be concise. 0.95. What is the ratio of the Rating (1=low 6=high) in Europe(all income levels) in 2009 to that in 2010?
Give a very brief answer. 0.98. What is the ratio of the Rating (1=low 6=high) of Sub-Saharan Africa (all income levels) in 2009 to that in 2010?
Ensure brevity in your answer.  0.98. What is the ratio of the Rating (1=low 6=high) in Armenia in 2009 to that in 2010?
Your answer should be compact. 1. What is the ratio of the Rating (1=low 6=high) in Europe(all income levels) in 2009 to that in 2011?
Provide a succinct answer. 1.01. What is the ratio of the Rating (1=low 6=high) in Sub-Saharan Africa (all income levels) in 2009 to that in 2011?
Provide a short and direct response. 0.93. What is the ratio of the Rating (1=low 6=high) in Uzbekistan in 2009 to that in 2011?
Offer a very short reply. 1. What is the ratio of the Rating (1=low 6=high) in Europe(all income levels) in 2009 to that in 2012?
Your answer should be very brief. 0.99. What is the ratio of the Rating (1=low 6=high) of Sub-Saharan Africa (all income levels) in 2009 to that in 2012?
Your response must be concise. 0.93. What is the ratio of the Rating (1=low 6=high) of Europe(all income levels) in 2009 to that in 2013?
Offer a very short reply. 0.99. What is the ratio of the Rating (1=low 6=high) in Sub-Saharan Africa (all income levels) in 2009 to that in 2013?
Offer a terse response. 0.95. What is the ratio of the Rating (1=low 6=high) of Europe(all income levels) in 2010 to that in 2011?
Provide a short and direct response. 1.03. What is the ratio of the Rating (1=low 6=high) in Sub-Saharan Africa (all income levels) in 2010 to that in 2011?
Keep it short and to the point. 0.95. What is the ratio of the Rating (1=low 6=high) of Europe(all income levels) in 2010 to that in 2012?
Offer a terse response. 1.01. What is the ratio of the Rating (1=low 6=high) in Sub-Saharan Africa (all income levels) in 2010 to that in 2012?
Provide a succinct answer. 0.95. What is the ratio of the Rating (1=low 6=high) of Uzbekistan in 2010 to that in 2012?
Offer a very short reply. 1. What is the ratio of the Rating (1=low 6=high) of Europe(all income levels) in 2010 to that in 2013?
Offer a very short reply. 1.01. What is the ratio of the Rating (1=low 6=high) of Sub-Saharan Africa (all income levels) in 2010 to that in 2013?
Keep it short and to the point. 0.97. What is the ratio of the Rating (1=low 6=high) of Armenia in 2010 to that in 2013?
Keep it short and to the point. 1. What is the ratio of the Rating (1=low 6=high) of Europe(all income levels) in 2011 to that in 2012?
Give a very brief answer. 0.98. What is the ratio of the Rating (1=low 6=high) of Sub-Saharan Africa (all income levels) in 2011 to that in 2012?
Make the answer very short. 1. What is the ratio of the Rating (1=low 6=high) of Armenia in 2011 to that in 2012?
Provide a short and direct response. 1. What is the ratio of the Rating (1=low 6=high) in Uzbekistan in 2011 to that in 2012?
Your answer should be compact. 1. What is the ratio of the Rating (1=low 6=high) in Europe(all income levels) in 2011 to that in 2013?
Your answer should be compact. 0.98. What is the ratio of the Rating (1=low 6=high) of Sub-Saharan Africa (all income levels) in 2011 to that in 2013?
Your answer should be compact. 1.01. What is the ratio of the Rating (1=low 6=high) of Armenia in 2011 to that in 2013?
Give a very brief answer. 1. What is the ratio of the Rating (1=low 6=high) in Sub-Saharan Africa (all income levels) in 2012 to that in 2013?
Ensure brevity in your answer.  1.01. What is the ratio of the Rating (1=low 6=high) of Armenia in 2012 to that in 2013?
Offer a very short reply. 1. What is the ratio of the Rating (1=low 6=high) of Uzbekistan in 2012 to that in 2013?
Your answer should be very brief. 1. What is the difference between the highest and the second highest Rating (1=low 6=high) in Europe(all income levels)?
Offer a terse response. 0.03. What is the difference between the highest and the second highest Rating (1=low 6=high) in Sub-Saharan Africa (all income levels)?
Your response must be concise. 0. What is the difference between the highest and the second highest Rating (1=low 6=high) of Armenia?
Keep it short and to the point. 0.5. What is the difference between the highest and the lowest Rating (1=low 6=high) in Europe(all income levels)?
Your answer should be compact. 0.1. What is the difference between the highest and the lowest Rating (1=low 6=high) of Sub-Saharan Africa (all income levels)?
Provide a short and direct response. 0.21. What is the difference between the highest and the lowest Rating (1=low 6=high) of Uzbekistan?
Keep it short and to the point. 0. 